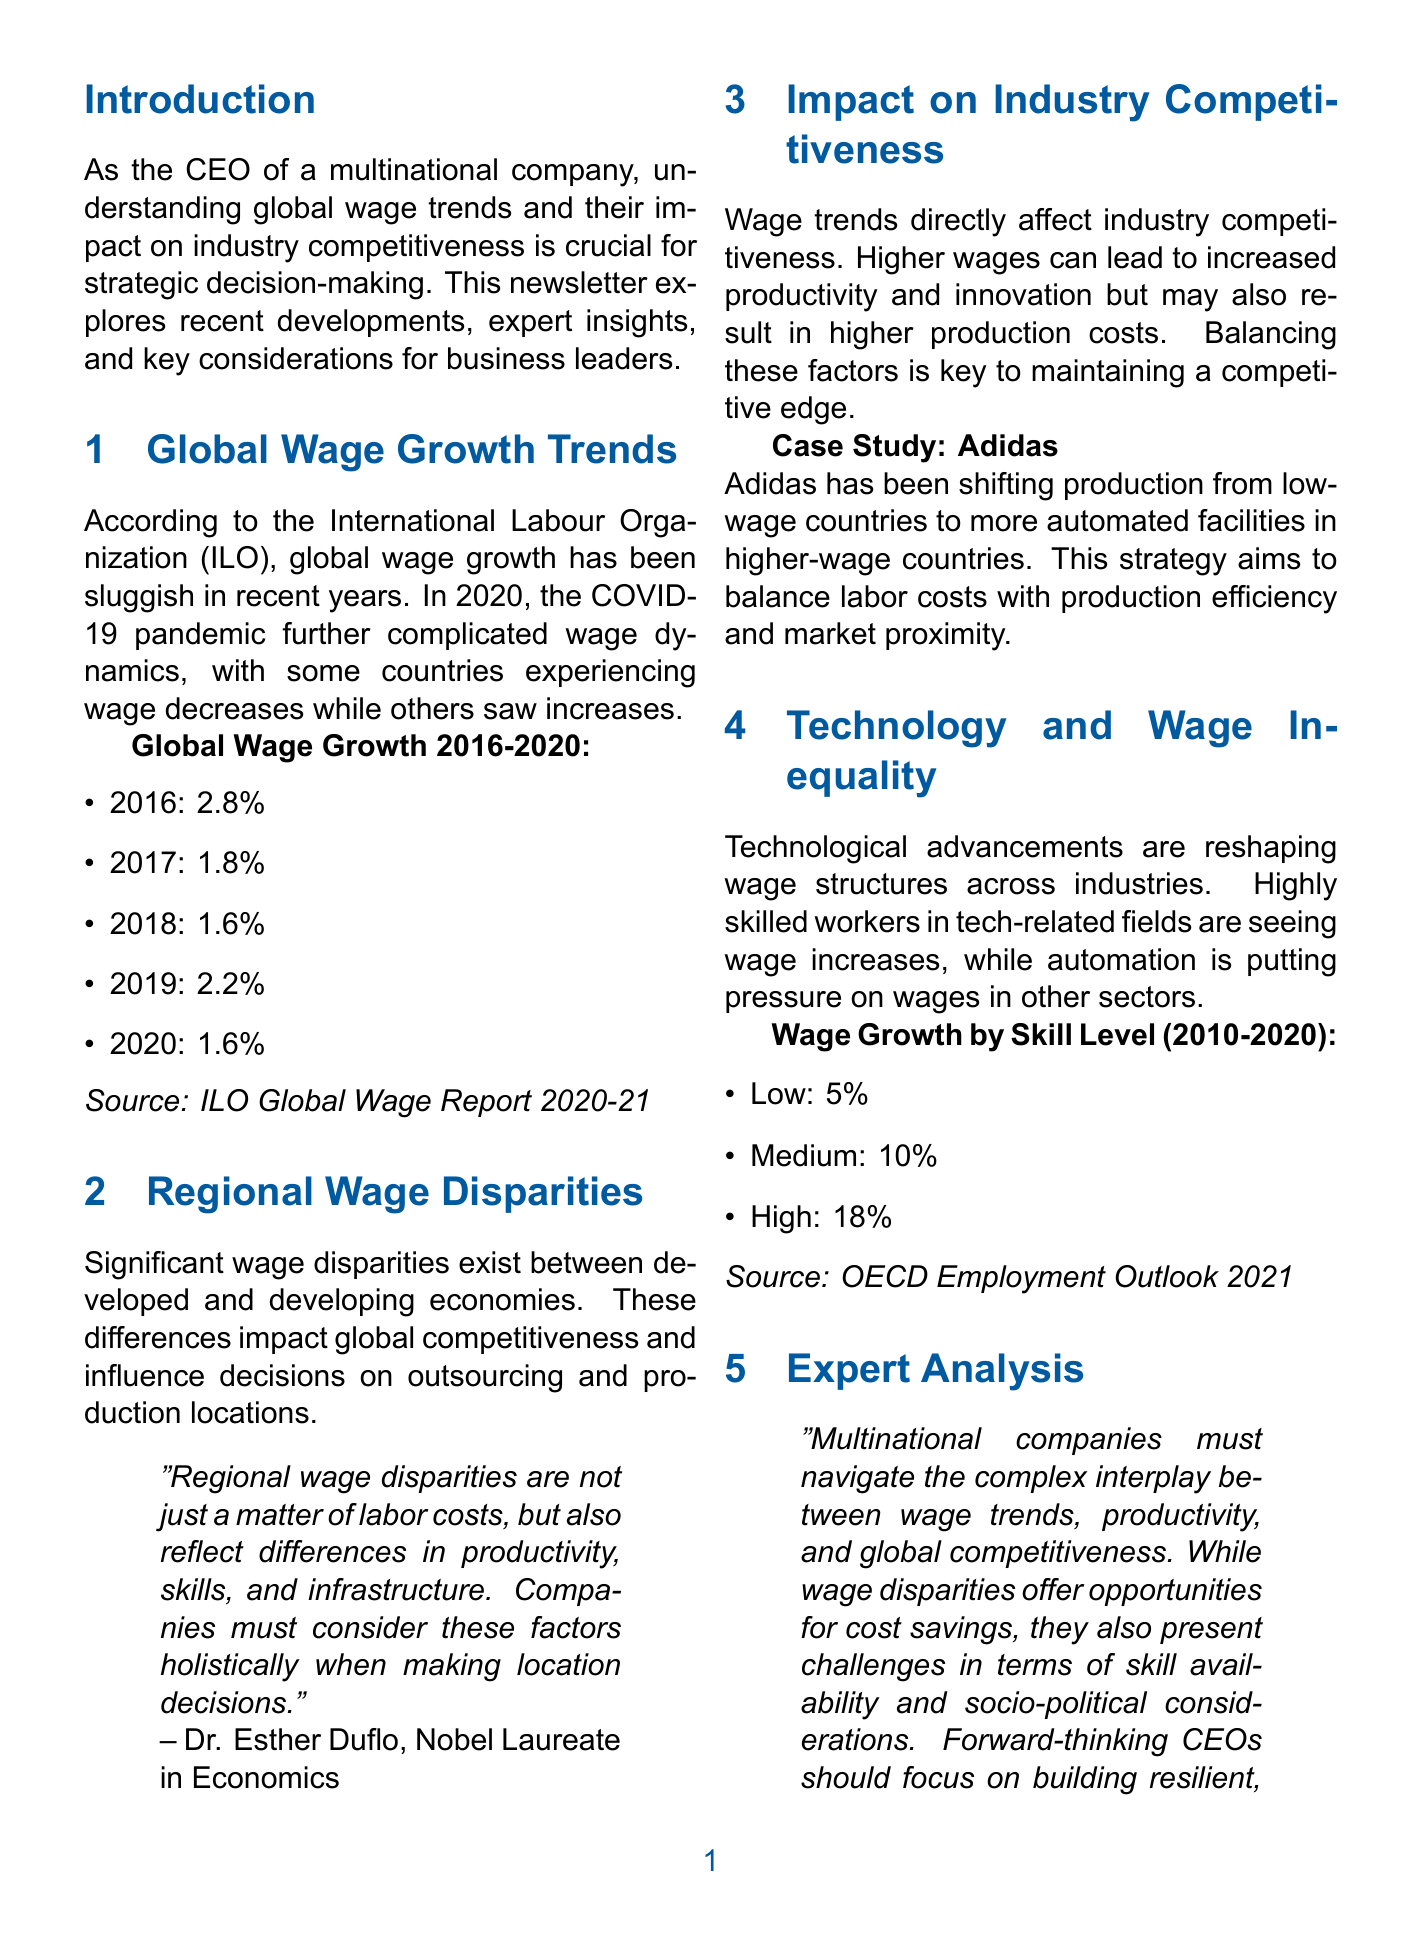what is the title of the newsletter? The title of the newsletter is stated at the beginning of the document.
Answer: Global Wage Trends: Navigating Industry Competitiveness in a Changing Landscape what was the global wage growth rate in 2019? The document provides specific growth rates for each year in the infographic section.
Answer: 2.2 who is the expert quoted in the Regional Wage Disparities section? The document mentions an expert along with their title in the quote section.
Answer: Dr. Esther Duflo what change has Adidas made regarding production locations? The document describes a strategy involving Adidas’ production decisions.
Answer: Shifting production from low-wage countries to higher-wage countries what was the wage growth percentage for high skill level workers from 2010 to 2020? The document includes wage growth data for different skill levels.
Answer: 18 what does Dr. Stefanie Stantcheva suggest companies should focus on? The analysis section provides insights on what CEOs should prioritize.
Answer: Building resilient, adaptable workforces which organization reported global wage growth trends? The source of the wage growth information is specified in the document.
Answer: International Labour Organization what is a key factor influencing outsourcing decisions according to the newsletter? The content discusses various elements that affect decisions around outsourcing.
Answer: Wage disparities 